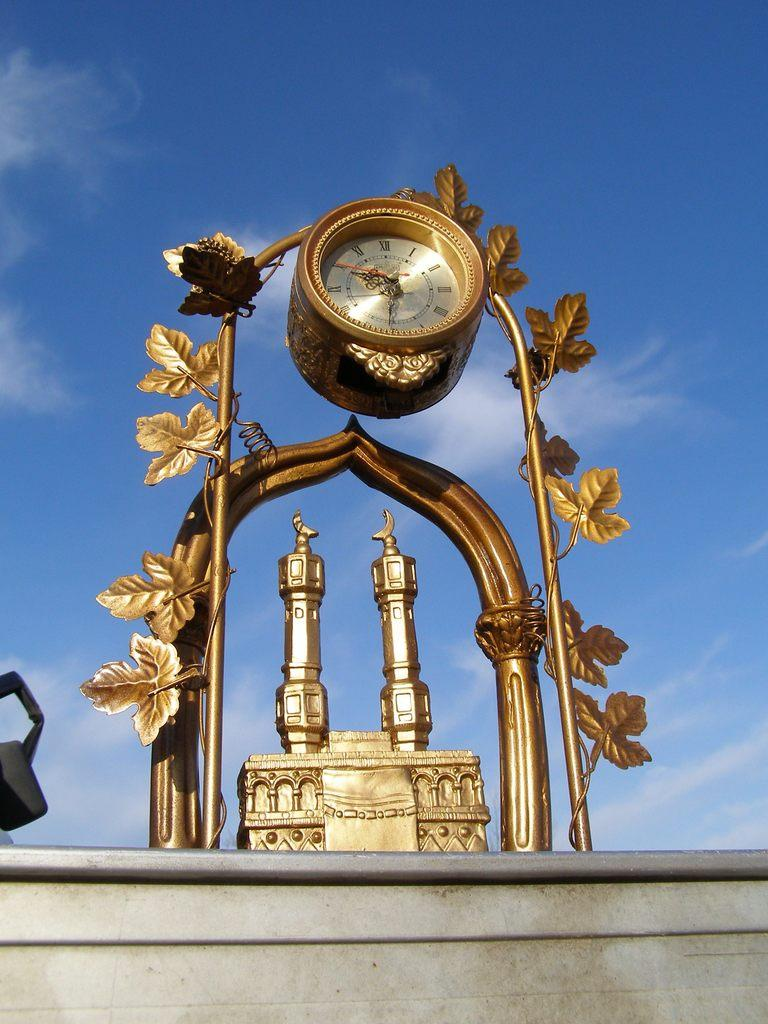Provide a one-sentence caption for the provided image. Golden clock which has the hands on number 6 and 9. 